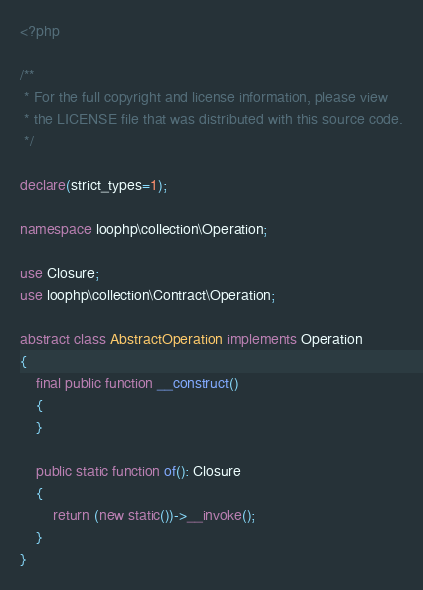Convert code to text. <code><loc_0><loc_0><loc_500><loc_500><_PHP_><?php

/**
 * For the full copyright and license information, please view
 * the LICENSE file that was distributed with this source code.
 */

declare(strict_types=1);

namespace loophp\collection\Operation;

use Closure;
use loophp\collection\Contract\Operation;

abstract class AbstractOperation implements Operation
{
    final public function __construct()
    {
    }

    public static function of(): Closure
    {
        return (new static())->__invoke();
    }
}
</code> 